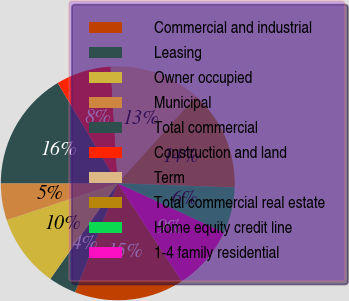Convert chart to OTSL. <chart><loc_0><loc_0><loc_500><loc_500><pie_chart><fcel>Commercial and industrial<fcel>Leasing<fcel>Owner occupied<fcel>Municipal<fcel>Total commercial<fcel>Construction and land<fcel>Term<fcel>Total commercial real estate<fcel>Home equity credit line<fcel>1-4 family residential<nl><fcel>15.15%<fcel>3.84%<fcel>10.13%<fcel>5.1%<fcel>16.41%<fcel>7.61%<fcel>12.64%<fcel>13.89%<fcel>6.36%<fcel>8.87%<nl></chart> 